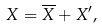Convert formula to latex. <formula><loc_0><loc_0><loc_500><loc_500>X = \overline { X } + X ^ { \prime } ,</formula> 